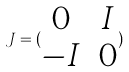Convert formula to latex. <formula><loc_0><loc_0><loc_500><loc_500>J = ( \begin{matrix} 0 & I \\ - I & 0 \end{matrix} )</formula> 